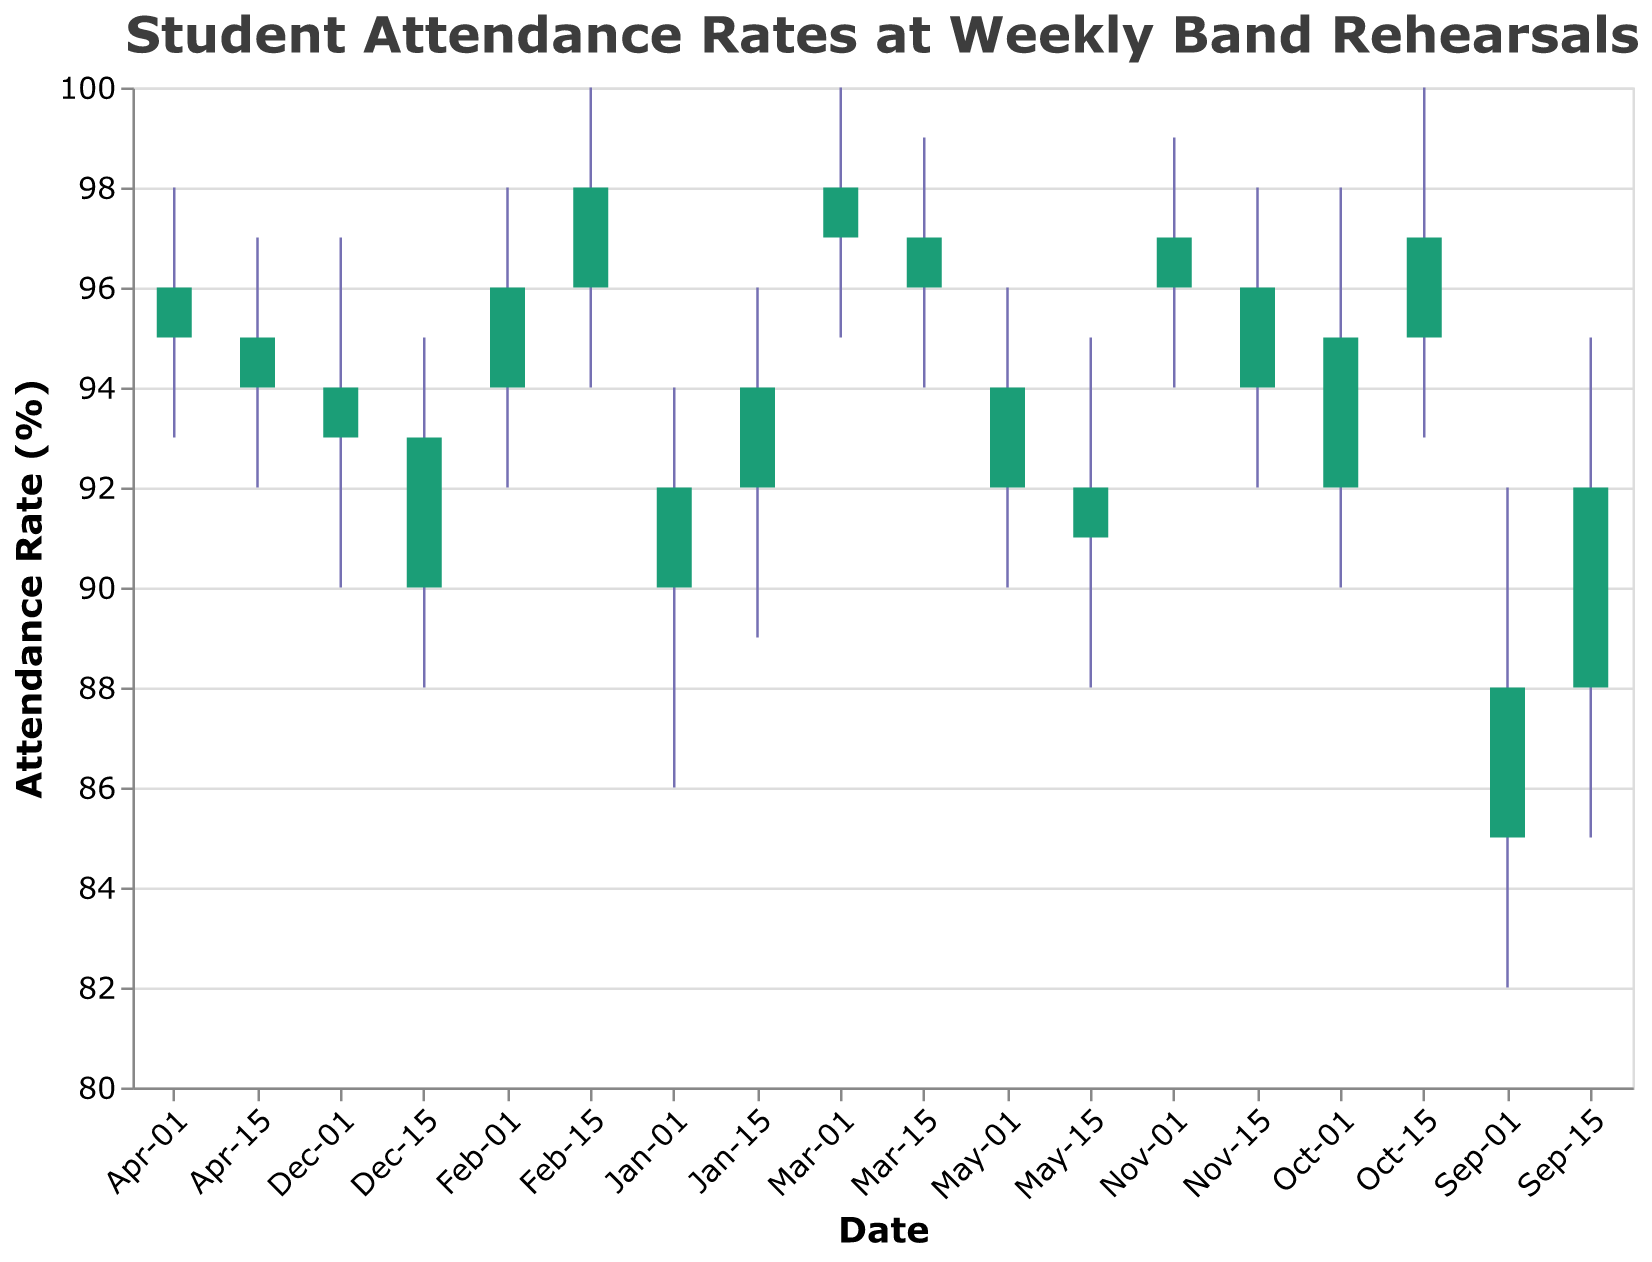What is the title of the chart? The title of the chart is located at the top and is usually descriptive. For this chart, it is "Student Attendance Rates at Weekly Band Rehearsals".
Answer: Student Attendance Rates at Weekly Band Rehearsals Which date had the highest attendance rate based on the closing value? To find the highest attendance rate based on the closing value, we look for the maximum 'Close' value in the chart. The highest 'Close' value is 98, which occurs on Feb-15.
Answer: Feb-15 What is the difference between the highest and lowest attendance rates on Oct-01? The highest attendance rate on Oct-01 is 98, and the lowest is 90. The difference is calculated by subtracting the lowest rate from the highest rate: 98 - 90 = 8.
Answer: 8 On which dates does the attendance rate close higher than it opens? We examine each date where the 'Close' value is greater than the 'Open' value. These dates are Sep-01, Sep-15, Oct-01, Oct-15, Jan-01, Feb-01, Feb-15.
Answer: Sep-01, Sep-15, Oct-01, Oct-15, Jan-01, Feb-01, Feb-15 Which month saw the biggest drop in attendance rates between two consecutive points? To find the biggest drop, we calculate the difference between closing values of consecutive dates and determine the maximum negative difference. From Oct-15 to Nov-15 the attendance rate dropped from 97 to 94, a difference of 3. Similarly, from Dec-01 to Dec-15 the attendance dropped from 93 to 90, a difference of 3. These are the biggest drops.
Answer: Oct-15 to Nov-01, Dec-01 to Dec-15 Compare the average attendance rate in February and March. Which is higher? Average attendance rate in February: (96+98) / 2 = 97. Average attendance rate in March: (97+96) / 2 = 96.5. Comparing these, February has a higher average attendance rate.
Answer: February How did the attendance rate trend change from September to December? We can observe the 'Close' values for each period ending in September and December. The trend from Sep-01 (88) to Dec-15 (90) indicates a slight decrease but relatively stable, oscillating between higher and lower values within this range.
Answer: Decreased slightly but stable What was the highest attendance rate recorded and when did it occur? To determine the highest attendance rate recorded, we look for the maximum 'High' value in the chart. The highest 'High' value is 100, occurring on Oct-15, Feb-15, and Mar-01.
Answer: Oct-15, Feb-15, Mar-01 Which period had the lowest opening attendance rate? To find the lowest opening attendance rate, we locate the smallest 'Open' value in the chart. The lowest 'Open' value is 85, which occurs on Sep-01.
Answer: Sep-01 